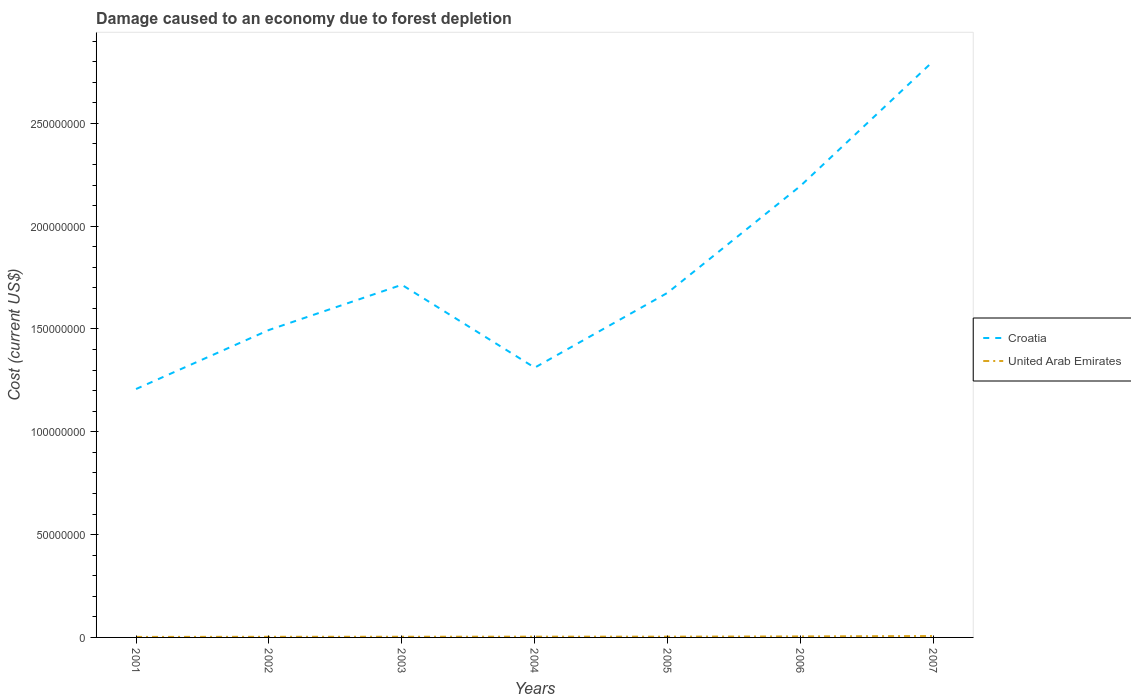How many different coloured lines are there?
Provide a succinct answer. 2. Is the number of lines equal to the number of legend labels?
Your answer should be compact. Yes. Across all years, what is the maximum cost of damage caused due to forest depletion in United Arab Emirates?
Keep it short and to the point. 2.50e+05. In which year was the cost of damage caused due to forest depletion in Croatia maximum?
Keep it short and to the point. 2001. What is the total cost of damage caused due to forest depletion in United Arab Emirates in the graph?
Provide a succinct answer. -1.15e+05. What is the difference between the highest and the second highest cost of damage caused due to forest depletion in United Arab Emirates?
Your answer should be very brief. 4.31e+05. What is the difference between the highest and the lowest cost of damage caused due to forest depletion in United Arab Emirates?
Keep it short and to the point. 2. How many lines are there?
Make the answer very short. 2. How many years are there in the graph?
Your answer should be very brief. 7. Are the values on the major ticks of Y-axis written in scientific E-notation?
Keep it short and to the point. No. Does the graph contain grids?
Provide a succinct answer. No. How are the legend labels stacked?
Your answer should be very brief. Vertical. What is the title of the graph?
Provide a short and direct response. Damage caused to an economy due to forest depletion. Does "Estonia" appear as one of the legend labels in the graph?
Provide a succinct answer. No. What is the label or title of the Y-axis?
Ensure brevity in your answer.  Cost (current US$). What is the Cost (current US$) of Croatia in 2001?
Make the answer very short. 1.21e+08. What is the Cost (current US$) of United Arab Emirates in 2001?
Your answer should be compact. 2.50e+05. What is the Cost (current US$) of Croatia in 2002?
Provide a short and direct response. 1.50e+08. What is the Cost (current US$) of United Arab Emirates in 2002?
Provide a succinct answer. 3.08e+05. What is the Cost (current US$) of Croatia in 2003?
Make the answer very short. 1.71e+08. What is the Cost (current US$) in United Arab Emirates in 2003?
Your answer should be compact. 3.32e+05. What is the Cost (current US$) in Croatia in 2004?
Give a very brief answer. 1.31e+08. What is the Cost (current US$) in United Arab Emirates in 2004?
Your answer should be compact. 3.74e+05. What is the Cost (current US$) of Croatia in 2005?
Offer a very short reply. 1.68e+08. What is the Cost (current US$) of United Arab Emirates in 2005?
Offer a terse response. 3.78e+05. What is the Cost (current US$) of Croatia in 2006?
Give a very brief answer. 2.20e+08. What is the Cost (current US$) of United Arab Emirates in 2006?
Give a very brief answer. 4.89e+05. What is the Cost (current US$) of Croatia in 2007?
Your response must be concise. 2.80e+08. What is the Cost (current US$) in United Arab Emirates in 2007?
Give a very brief answer. 6.81e+05. Across all years, what is the maximum Cost (current US$) of Croatia?
Your answer should be compact. 2.80e+08. Across all years, what is the maximum Cost (current US$) in United Arab Emirates?
Ensure brevity in your answer.  6.81e+05. Across all years, what is the minimum Cost (current US$) in Croatia?
Ensure brevity in your answer.  1.21e+08. Across all years, what is the minimum Cost (current US$) in United Arab Emirates?
Provide a short and direct response. 2.50e+05. What is the total Cost (current US$) of Croatia in the graph?
Your answer should be very brief. 1.24e+09. What is the total Cost (current US$) of United Arab Emirates in the graph?
Your answer should be compact. 2.81e+06. What is the difference between the Cost (current US$) in Croatia in 2001 and that in 2002?
Offer a very short reply. -2.87e+07. What is the difference between the Cost (current US$) of United Arab Emirates in 2001 and that in 2002?
Your response must be concise. -5.80e+04. What is the difference between the Cost (current US$) in Croatia in 2001 and that in 2003?
Give a very brief answer. -5.07e+07. What is the difference between the Cost (current US$) of United Arab Emirates in 2001 and that in 2003?
Offer a very short reply. -8.17e+04. What is the difference between the Cost (current US$) of Croatia in 2001 and that in 2004?
Provide a succinct answer. -1.04e+07. What is the difference between the Cost (current US$) of United Arab Emirates in 2001 and that in 2004?
Provide a succinct answer. -1.24e+05. What is the difference between the Cost (current US$) of Croatia in 2001 and that in 2005?
Provide a short and direct response. -4.68e+07. What is the difference between the Cost (current US$) in United Arab Emirates in 2001 and that in 2005?
Offer a very short reply. -1.28e+05. What is the difference between the Cost (current US$) of Croatia in 2001 and that in 2006?
Keep it short and to the point. -9.88e+07. What is the difference between the Cost (current US$) of United Arab Emirates in 2001 and that in 2006?
Your response must be concise. -2.39e+05. What is the difference between the Cost (current US$) of Croatia in 2001 and that in 2007?
Ensure brevity in your answer.  -1.60e+08. What is the difference between the Cost (current US$) in United Arab Emirates in 2001 and that in 2007?
Ensure brevity in your answer.  -4.31e+05. What is the difference between the Cost (current US$) in Croatia in 2002 and that in 2003?
Provide a succinct answer. -2.20e+07. What is the difference between the Cost (current US$) of United Arab Emirates in 2002 and that in 2003?
Offer a very short reply. -2.37e+04. What is the difference between the Cost (current US$) of Croatia in 2002 and that in 2004?
Provide a succinct answer. 1.83e+07. What is the difference between the Cost (current US$) in United Arab Emirates in 2002 and that in 2004?
Give a very brief answer. -6.62e+04. What is the difference between the Cost (current US$) of Croatia in 2002 and that in 2005?
Make the answer very short. -1.81e+07. What is the difference between the Cost (current US$) of United Arab Emirates in 2002 and that in 2005?
Offer a very short reply. -6.98e+04. What is the difference between the Cost (current US$) in Croatia in 2002 and that in 2006?
Your response must be concise. -7.01e+07. What is the difference between the Cost (current US$) in United Arab Emirates in 2002 and that in 2006?
Keep it short and to the point. -1.81e+05. What is the difference between the Cost (current US$) in Croatia in 2002 and that in 2007?
Make the answer very short. -1.31e+08. What is the difference between the Cost (current US$) of United Arab Emirates in 2002 and that in 2007?
Ensure brevity in your answer.  -3.73e+05. What is the difference between the Cost (current US$) in Croatia in 2003 and that in 2004?
Provide a short and direct response. 4.03e+07. What is the difference between the Cost (current US$) in United Arab Emirates in 2003 and that in 2004?
Offer a very short reply. -4.25e+04. What is the difference between the Cost (current US$) of Croatia in 2003 and that in 2005?
Your response must be concise. 3.88e+06. What is the difference between the Cost (current US$) in United Arab Emirates in 2003 and that in 2005?
Ensure brevity in your answer.  -4.60e+04. What is the difference between the Cost (current US$) in Croatia in 2003 and that in 2006?
Your answer should be compact. -4.81e+07. What is the difference between the Cost (current US$) in United Arab Emirates in 2003 and that in 2006?
Provide a succinct answer. -1.57e+05. What is the difference between the Cost (current US$) in Croatia in 2003 and that in 2007?
Ensure brevity in your answer.  -1.09e+08. What is the difference between the Cost (current US$) in United Arab Emirates in 2003 and that in 2007?
Offer a terse response. -3.49e+05. What is the difference between the Cost (current US$) in Croatia in 2004 and that in 2005?
Offer a very short reply. -3.64e+07. What is the difference between the Cost (current US$) in United Arab Emirates in 2004 and that in 2005?
Keep it short and to the point. -3575.79. What is the difference between the Cost (current US$) in Croatia in 2004 and that in 2006?
Offer a terse response. -8.84e+07. What is the difference between the Cost (current US$) in United Arab Emirates in 2004 and that in 2006?
Provide a short and direct response. -1.15e+05. What is the difference between the Cost (current US$) in Croatia in 2004 and that in 2007?
Your response must be concise. -1.49e+08. What is the difference between the Cost (current US$) of United Arab Emirates in 2004 and that in 2007?
Provide a short and direct response. -3.06e+05. What is the difference between the Cost (current US$) in Croatia in 2005 and that in 2006?
Keep it short and to the point. -5.20e+07. What is the difference between the Cost (current US$) of United Arab Emirates in 2005 and that in 2006?
Ensure brevity in your answer.  -1.11e+05. What is the difference between the Cost (current US$) of Croatia in 2005 and that in 2007?
Offer a very short reply. -1.13e+08. What is the difference between the Cost (current US$) in United Arab Emirates in 2005 and that in 2007?
Your response must be concise. -3.03e+05. What is the difference between the Cost (current US$) of Croatia in 2006 and that in 2007?
Offer a very short reply. -6.07e+07. What is the difference between the Cost (current US$) of United Arab Emirates in 2006 and that in 2007?
Your answer should be very brief. -1.92e+05. What is the difference between the Cost (current US$) in Croatia in 2001 and the Cost (current US$) in United Arab Emirates in 2002?
Offer a very short reply. 1.21e+08. What is the difference between the Cost (current US$) in Croatia in 2001 and the Cost (current US$) in United Arab Emirates in 2003?
Provide a succinct answer. 1.20e+08. What is the difference between the Cost (current US$) in Croatia in 2001 and the Cost (current US$) in United Arab Emirates in 2004?
Ensure brevity in your answer.  1.20e+08. What is the difference between the Cost (current US$) in Croatia in 2001 and the Cost (current US$) in United Arab Emirates in 2005?
Your response must be concise. 1.20e+08. What is the difference between the Cost (current US$) of Croatia in 2001 and the Cost (current US$) of United Arab Emirates in 2006?
Offer a very short reply. 1.20e+08. What is the difference between the Cost (current US$) of Croatia in 2001 and the Cost (current US$) of United Arab Emirates in 2007?
Provide a short and direct response. 1.20e+08. What is the difference between the Cost (current US$) in Croatia in 2002 and the Cost (current US$) in United Arab Emirates in 2003?
Offer a very short reply. 1.49e+08. What is the difference between the Cost (current US$) in Croatia in 2002 and the Cost (current US$) in United Arab Emirates in 2004?
Make the answer very short. 1.49e+08. What is the difference between the Cost (current US$) of Croatia in 2002 and the Cost (current US$) of United Arab Emirates in 2005?
Your answer should be compact. 1.49e+08. What is the difference between the Cost (current US$) in Croatia in 2002 and the Cost (current US$) in United Arab Emirates in 2006?
Provide a short and direct response. 1.49e+08. What is the difference between the Cost (current US$) in Croatia in 2002 and the Cost (current US$) in United Arab Emirates in 2007?
Your response must be concise. 1.49e+08. What is the difference between the Cost (current US$) of Croatia in 2003 and the Cost (current US$) of United Arab Emirates in 2004?
Offer a terse response. 1.71e+08. What is the difference between the Cost (current US$) of Croatia in 2003 and the Cost (current US$) of United Arab Emirates in 2005?
Ensure brevity in your answer.  1.71e+08. What is the difference between the Cost (current US$) of Croatia in 2003 and the Cost (current US$) of United Arab Emirates in 2006?
Offer a terse response. 1.71e+08. What is the difference between the Cost (current US$) in Croatia in 2003 and the Cost (current US$) in United Arab Emirates in 2007?
Ensure brevity in your answer.  1.71e+08. What is the difference between the Cost (current US$) of Croatia in 2004 and the Cost (current US$) of United Arab Emirates in 2005?
Make the answer very short. 1.31e+08. What is the difference between the Cost (current US$) in Croatia in 2004 and the Cost (current US$) in United Arab Emirates in 2006?
Make the answer very short. 1.31e+08. What is the difference between the Cost (current US$) of Croatia in 2004 and the Cost (current US$) of United Arab Emirates in 2007?
Offer a very short reply. 1.31e+08. What is the difference between the Cost (current US$) of Croatia in 2005 and the Cost (current US$) of United Arab Emirates in 2006?
Your answer should be very brief. 1.67e+08. What is the difference between the Cost (current US$) of Croatia in 2005 and the Cost (current US$) of United Arab Emirates in 2007?
Your response must be concise. 1.67e+08. What is the difference between the Cost (current US$) of Croatia in 2006 and the Cost (current US$) of United Arab Emirates in 2007?
Your answer should be very brief. 2.19e+08. What is the average Cost (current US$) of Croatia per year?
Provide a short and direct response. 1.77e+08. What is the average Cost (current US$) of United Arab Emirates per year?
Offer a terse response. 4.02e+05. In the year 2001, what is the difference between the Cost (current US$) of Croatia and Cost (current US$) of United Arab Emirates?
Offer a very short reply. 1.21e+08. In the year 2002, what is the difference between the Cost (current US$) in Croatia and Cost (current US$) in United Arab Emirates?
Keep it short and to the point. 1.49e+08. In the year 2003, what is the difference between the Cost (current US$) in Croatia and Cost (current US$) in United Arab Emirates?
Make the answer very short. 1.71e+08. In the year 2004, what is the difference between the Cost (current US$) in Croatia and Cost (current US$) in United Arab Emirates?
Your answer should be very brief. 1.31e+08. In the year 2005, what is the difference between the Cost (current US$) of Croatia and Cost (current US$) of United Arab Emirates?
Your response must be concise. 1.67e+08. In the year 2006, what is the difference between the Cost (current US$) of Croatia and Cost (current US$) of United Arab Emirates?
Provide a succinct answer. 2.19e+08. In the year 2007, what is the difference between the Cost (current US$) of Croatia and Cost (current US$) of United Arab Emirates?
Provide a succinct answer. 2.80e+08. What is the ratio of the Cost (current US$) of Croatia in 2001 to that in 2002?
Your response must be concise. 0.81. What is the ratio of the Cost (current US$) of United Arab Emirates in 2001 to that in 2002?
Your answer should be very brief. 0.81. What is the ratio of the Cost (current US$) in Croatia in 2001 to that in 2003?
Give a very brief answer. 0.7. What is the ratio of the Cost (current US$) in United Arab Emirates in 2001 to that in 2003?
Provide a short and direct response. 0.75. What is the ratio of the Cost (current US$) of Croatia in 2001 to that in 2004?
Give a very brief answer. 0.92. What is the ratio of the Cost (current US$) of United Arab Emirates in 2001 to that in 2004?
Your response must be concise. 0.67. What is the ratio of the Cost (current US$) in Croatia in 2001 to that in 2005?
Make the answer very short. 0.72. What is the ratio of the Cost (current US$) in United Arab Emirates in 2001 to that in 2005?
Give a very brief answer. 0.66. What is the ratio of the Cost (current US$) in Croatia in 2001 to that in 2006?
Keep it short and to the point. 0.55. What is the ratio of the Cost (current US$) in United Arab Emirates in 2001 to that in 2006?
Give a very brief answer. 0.51. What is the ratio of the Cost (current US$) in Croatia in 2001 to that in 2007?
Provide a short and direct response. 0.43. What is the ratio of the Cost (current US$) of United Arab Emirates in 2001 to that in 2007?
Give a very brief answer. 0.37. What is the ratio of the Cost (current US$) in Croatia in 2002 to that in 2003?
Give a very brief answer. 0.87. What is the ratio of the Cost (current US$) in United Arab Emirates in 2002 to that in 2003?
Provide a succinct answer. 0.93. What is the ratio of the Cost (current US$) in Croatia in 2002 to that in 2004?
Offer a terse response. 1.14. What is the ratio of the Cost (current US$) in United Arab Emirates in 2002 to that in 2004?
Your answer should be very brief. 0.82. What is the ratio of the Cost (current US$) in Croatia in 2002 to that in 2005?
Give a very brief answer. 0.89. What is the ratio of the Cost (current US$) in United Arab Emirates in 2002 to that in 2005?
Your answer should be compact. 0.82. What is the ratio of the Cost (current US$) of Croatia in 2002 to that in 2006?
Provide a short and direct response. 0.68. What is the ratio of the Cost (current US$) of United Arab Emirates in 2002 to that in 2006?
Make the answer very short. 0.63. What is the ratio of the Cost (current US$) in Croatia in 2002 to that in 2007?
Ensure brevity in your answer.  0.53. What is the ratio of the Cost (current US$) of United Arab Emirates in 2002 to that in 2007?
Provide a succinct answer. 0.45. What is the ratio of the Cost (current US$) of Croatia in 2003 to that in 2004?
Make the answer very short. 1.31. What is the ratio of the Cost (current US$) in United Arab Emirates in 2003 to that in 2004?
Your response must be concise. 0.89. What is the ratio of the Cost (current US$) of Croatia in 2003 to that in 2005?
Offer a terse response. 1.02. What is the ratio of the Cost (current US$) in United Arab Emirates in 2003 to that in 2005?
Your answer should be very brief. 0.88. What is the ratio of the Cost (current US$) in Croatia in 2003 to that in 2006?
Your response must be concise. 0.78. What is the ratio of the Cost (current US$) in United Arab Emirates in 2003 to that in 2006?
Provide a short and direct response. 0.68. What is the ratio of the Cost (current US$) in Croatia in 2003 to that in 2007?
Give a very brief answer. 0.61. What is the ratio of the Cost (current US$) of United Arab Emirates in 2003 to that in 2007?
Your answer should be compact. 0.49. What is the ratio of the Cost (current US$) in Croatia in 2004 to that in 2005?
Make the answer very short. 0.78. What is the ratio of the Cost (current US$) in Croatia in 2004 to that in 2006?
Offer a very short reply. 0.6. What is the ratio of the Cost (current US$) of United Arab Emirates in 2004 to that in 2006?
Provide a succinct answer. 0.77. What is the ratio of the Cost (current US$) in Croatia in 2004 to that in 2007?
Provide a succinct answer. 0.47. What is the ratio of the Cost (current US$) in United Arab Emirates in 2004 to that in 2007?
Offer a terse response. 0.55. What is the ratio of the Cost (current US$) of Croatia in 2005 to that in 2006?
Your answer should be compact. 0.76. What is the ratio of the Cost (current US$) in United Arab Emirates in 2005 to that in 2006?
Your answer should be compact. 0.77. What is the ratio of the Cost (current US$) in Croatia in 2005 to that in 2007?
Provide a succinct answer. 0.6. What is the ratio of the Cost (current US$) of United Arab Emirates in 2005 to that in 2007?
Ensure brevity in your answer.  0.56. What is the ratio of the Cost (current US$) in Croatia in 2006 to that in 2007?
Offer a very short reply. 0.78. What is the ratio of the Cost (current US$) in United Arab Emirates in 2006 to that in 2007?
Your answer should be compact. 0.72. What is the difference between the highest and the second highest Cost (current US$) in Croatia?
Make the answer very short. 6.07e+07. What is the difference between the highest and the second highest Cost (current US$) of United Arab Emirates?
Your response must be concise. 1.92e+05. What is the difference between the highest and the lowest Cost (current US$) in Croatia?
Offer a very short reply. 1.60e+08. What is the difference between the highest and the lowest Cost (current US$) of United Arab Emirates?
Make the answer very short. 4.31e+05. 